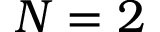Convert formula to latex. <formula><loc_0><loc_0><loc_500><loc_500>N = 2</formula> 